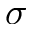Convert formula to latex. <formula><loc_0><loc_0><loc_500><loc_500>\sigma</formula> 